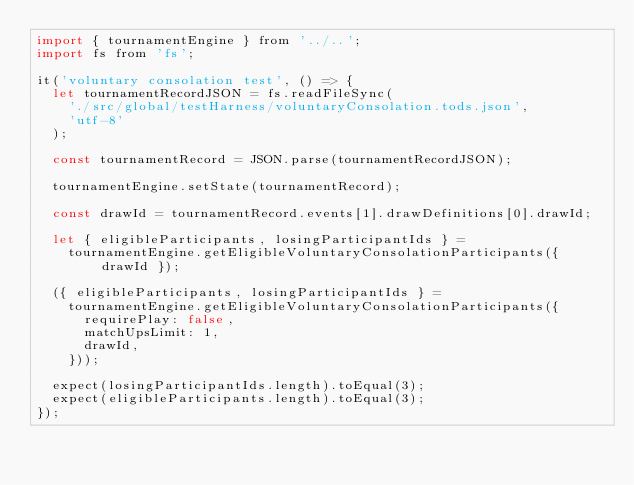<code> <loc_0><loc_0><loc_500><loc_500><_JavaScript_>import { tournamentEngine } from '../..';
import fs from 'fs';

it('voluntary consolation test', () => {
  let tournamentRecordJSON = fs.readFileSync(
    './src/global/testHarness/voluntaryConsolation.tods.json',
    'utf-8'
  );

  const tournamentRecord = JSON.parse(tournamentRecordJSON);

  tournamentEngine.setState(tournamentRecord);

  const drawId = tournamentRecord.events[1].drawDefinitions[0].drawId;

  let { eligibleParticipants, losingParticipantIds } =
    tournamentEngine.getEligibleVoluntaryConsolationParticipants({ drawId });

  ({ eligibleParticipants, losingParticipantIds } =
    tournamentEngine.getEligibleVoluntaryConsolationParticipants({
      requirePlay: false,
      matchUpsLimit: 1,
      drawId,
    }));

  expect(losingParticipantIds.length).toEqual(3);
  expect(eligibleParticipants.length).toEqual(3);
});
</code> 